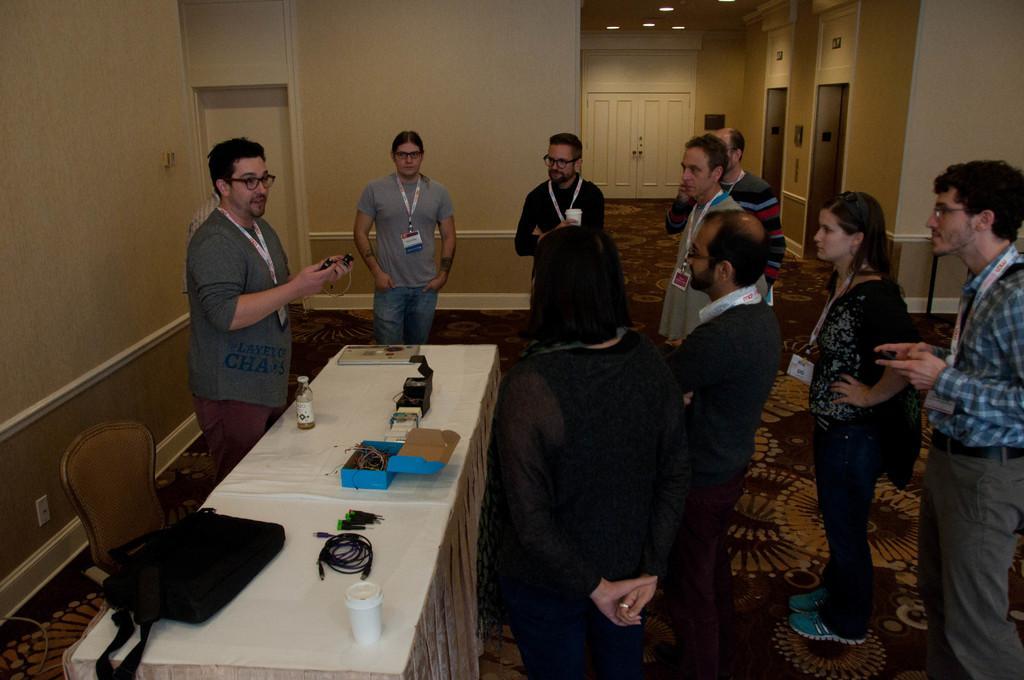Could you give a brief overview of what you see in this image? This persons are standing. On this table there is a bottle, box, cable, bag and cup. Beside this table there is a chair. This are door. Every person wore an Id card. Floor with carpet. 